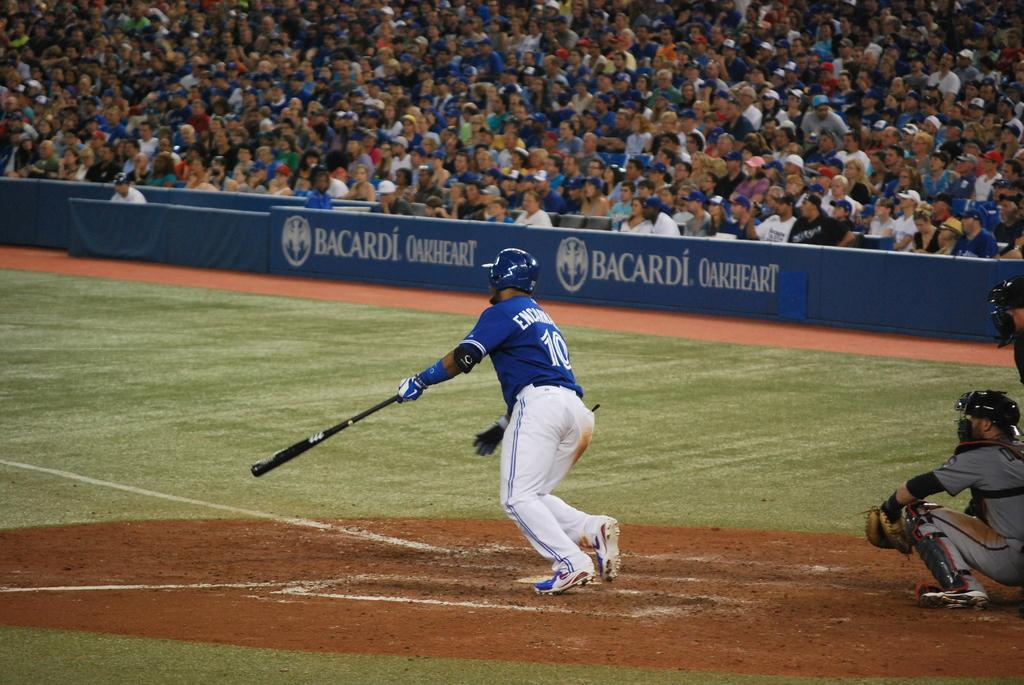<image>
Render a clear and concise summary of the photo. A Bacardi ad is along the wall of the baseball field. 